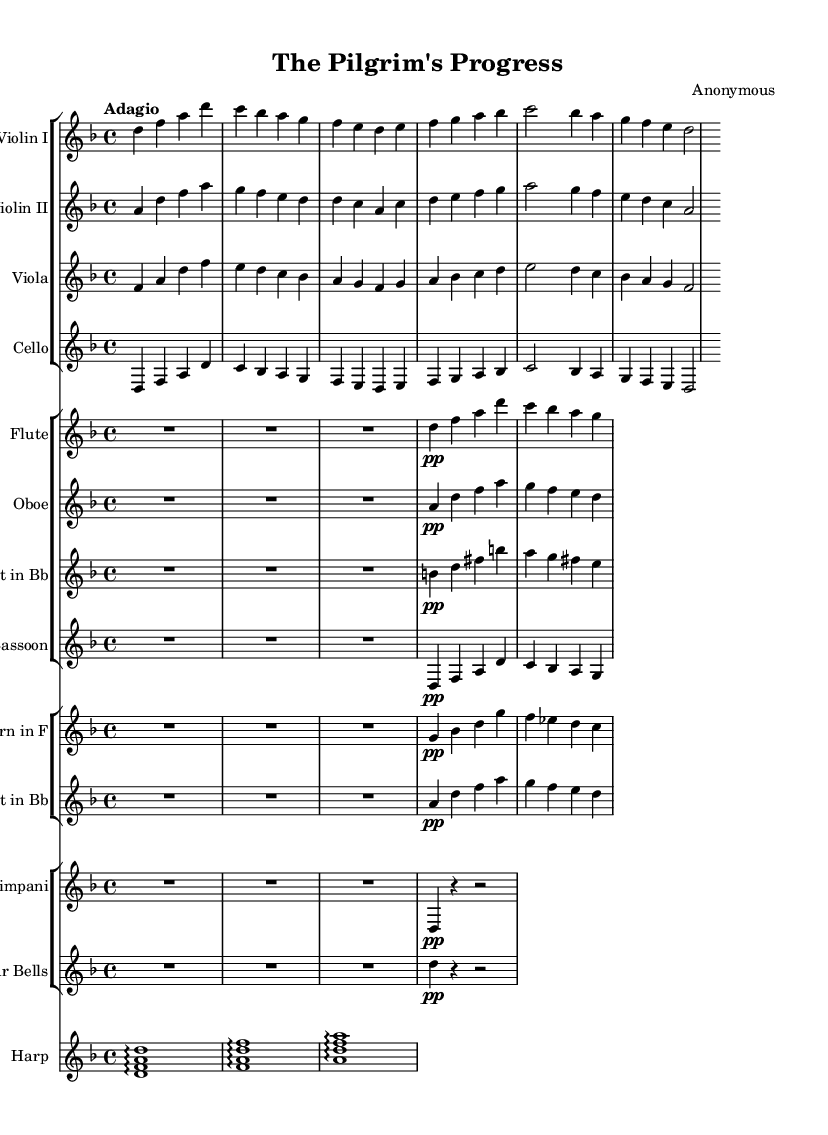What is the key signature of this music? The key signature is indicated at the beginning of the music sheet. In this case, it is D minor, which has one flat (B flat).
Answer: D minor What is the time signature of this music? The time signature is found near the beginning of the music. Here, it is indicated as 4/4, meaning four beats in a measure.
Answer: 4/4 What is the tempo marking of this composition? The tempo marking is displayed above the staff, indicating the speed of the music. In this sheet, it is noted as Adagio, which means a slow tempo.
Answer: Adagio How many instruments are featured in this score? To determine the number of instruments, count each unique staff group. In this score, there are six distinct instrument groups represented.
Answer: Six Which stage of faith might be represented by the use of the harp in this symphonic poem? The harp is often associated with soothing and spiritual imagery; its presence could depict a stage of reflection or enlightenment in the journey of the soul.
Answer: Reflection What mood is primarily conveyed by the flute part in this music? The flute is marked with a soft dynamic (pp), suggesting a gentle and introspective mood, typical for conveying serenity or contemplation in music.
Answer: Serenity Which instrument plays the main melodic line in this passage? By examining the score, the Violin I is primarily responsible for the main melodic line, presenting the primary themes throughout the piece.
Answer: Violin I 